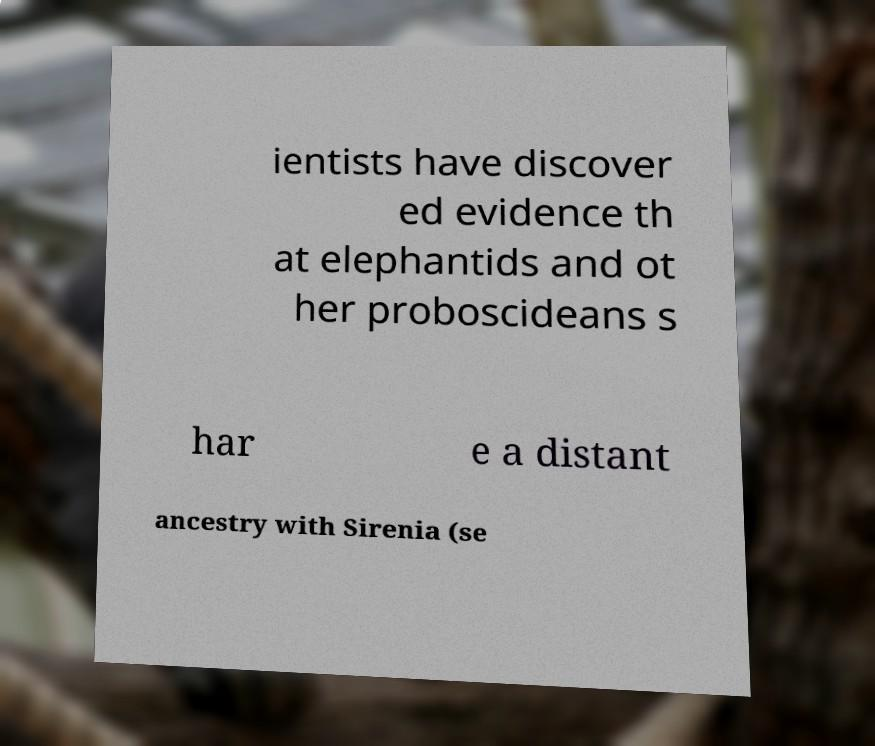Can you read and provide the text displayed in the image?This photo seems to have some interesting text. Can you extract and type it out for me? ientists have discover ed evidence th at elephantids and ot her proboscideans s har e a distant ancestry with Sirenia (se 